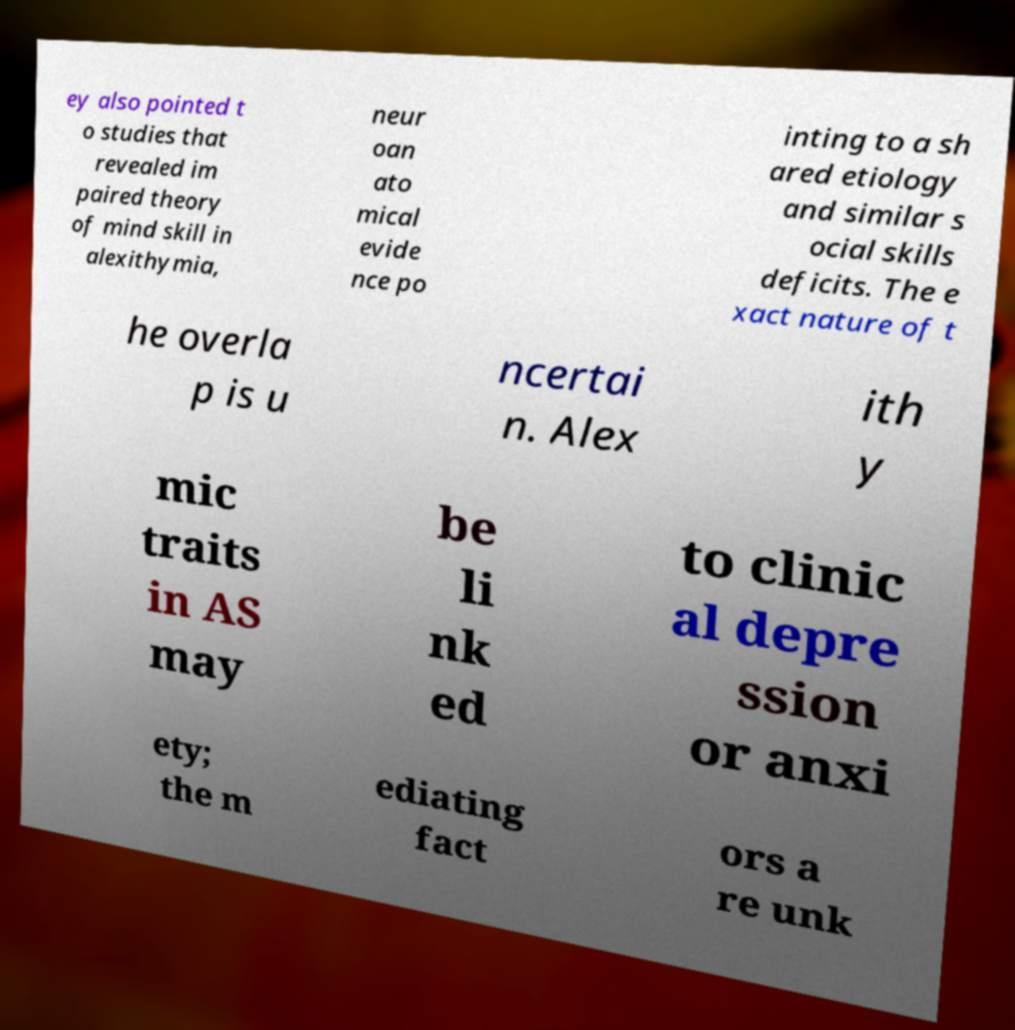Please read and relay the text visible in this image. What does it say? ey also pointed t o studies that revealed im paired theory of mind skill in alexithymia, neur oan ato mical evide nce po inting to a sh ared etiology and similar s ocial skills deficits. The e xact nature of t he overla p is u ncertai n. Alex ith y mic traits in AS may be li nk ed to clinic al depre ssion or anxi ety; the m ediating fact ors a re unk 